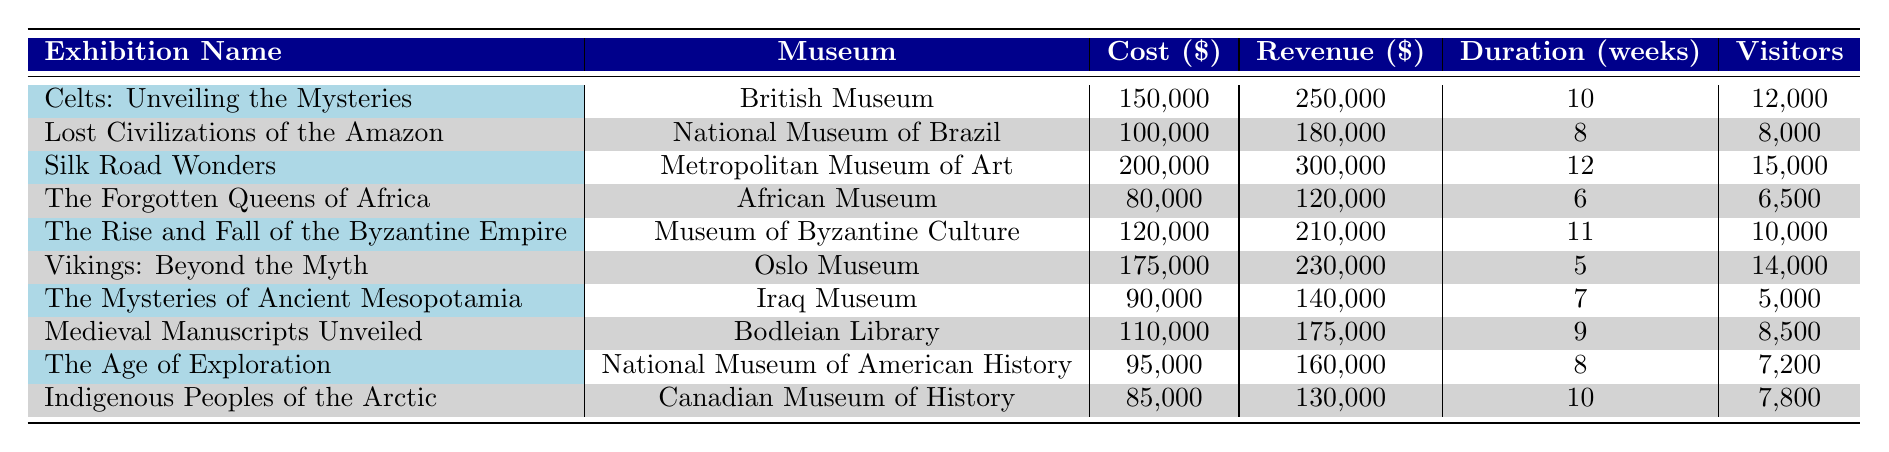What is the total revenue generated by the exhibition "Silk Road Wonders"? The revenue generated by "Silk Road Wonders," as shown in the table, is 300,000.
Answer: 300000 Which exhibition had the highest cost? Upon examining the cost column, "Silk Road Wonders" has the highest cost, which is 200,000.
Answer: 200000 What is the average cost of all exhibitions listed? To find the average cost, sum all the costs: 150000 + 100000 + 200000 + 80000 + 120000 + 175000 + 90000 + 110000 + 95000 + 85000 = 1,260,000. Then, divide by the number of exhibitions (10): 1,260,000 / 10 = 126,000.
Answer: 126000 Did the "The Forgotten Queens of Africa" generate more revenue than it cost? The cost of "The Forgotten Queens of Africa" is 80,000, and the revenue generated is 120,000. Since 120,000 is greater than 80,000, it did generate more revenue than it cost.
Answer: Yes Which exhibition had the least number of visitors? In the visitor count column, "The Mysteries of Ancient Mesopotamia" had the least number of visitors, totaling 5,000.
Answer: 5000 What is the total duration in weeks for exhibitions held in museums that generated over 200,000 in revenue? First, identify exhibitions with revenue over 200,000: "Silk Road Wonders" (12 weeks) and "Celts: Unveiling the Mysteries" (10 weeks). Then, total their durations: 12 + 10 = 22 weeks.
Answer: 22 How many exhibitions had costs below 100,000? By checking the cost column, the exhibitions "The Forgotten Queens of Africa" (80,000), "The Mysteries of Ancient Mesopotamia" (90,000), and "Indigenous Peoples of the Arctic" (85,000) are below 100,000, which totals to 3 exhibitions.
Answer: 3 What is the difference in revenue between the highest and lowest revenue-generating exhibitions? The highest revenue is from "Silk Road Wonders" at 300,000, and the lowest is "The Mysteries of Ancient Mesopotamia" at 140,000. The difference is calculated as 300,000 - 140,000 = 160,000.
Answer: 160000 Which museum hosted an exhibition with a visitor count of over 10,000 and generated less than 250,000 in revenue? In the table, the exhibition "The Rise and Fall of the Byzantine Empire" at the Museum of Byzantine Culture had 10,000 visitors and generated 210,000 in revenue, meeting both criteria.
Answer: Museum of Byzantine Culture 